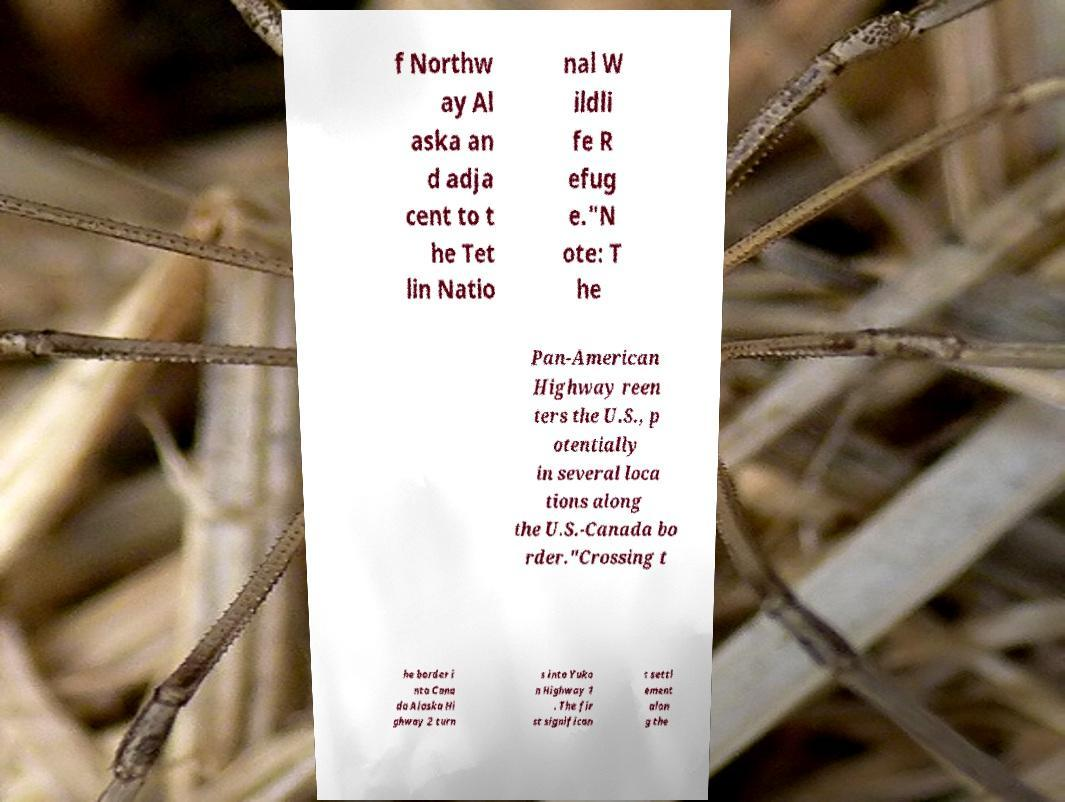Can you accurately transcribe the text from the provided image for me? f Northw ay Al aska an d adja cent to t he Tet lin Natio nal W ildli fe R efug e."N ote: T he Pan-American Highway reen ters the U.S., p otentially in several loca tions along the U.S.-Canada bo rder."Crossing t he border i nto Cana da Alaska Hi ghway 2 turn s into Yuko n Highway 1 . The fir st significan t settl ement alon g the 